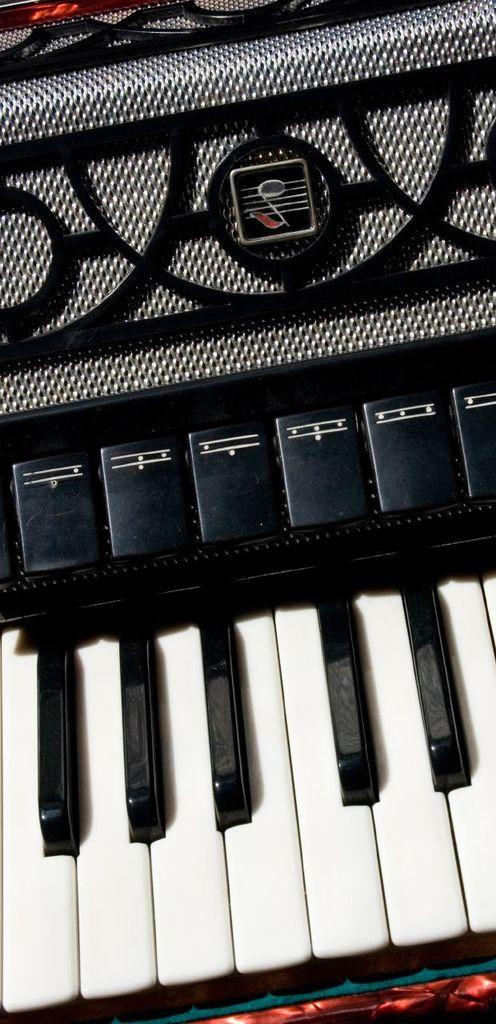How would you summarize this image in a sentence or two? In this image I can see a piano. 